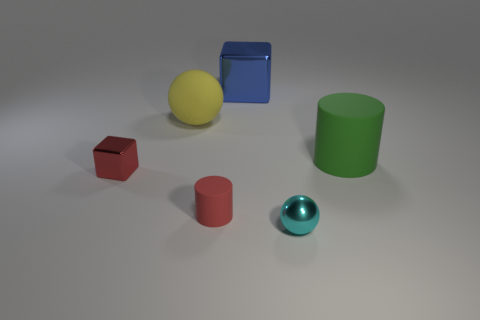Add 4 large cyan rubber things. How many objects exist? 10 Subtract all cylinders. How many objects are left? 4 Subtract all red matte balls. Subtract all small rubber objects. How many objects are left? 5 Add 6 green matte things. How many green matte things are left? 7 Add 5 big gray matte spheres. How many big gray matte spheres exist? 5 Subtract 0 cyan blocks. How many objects are left? 6 